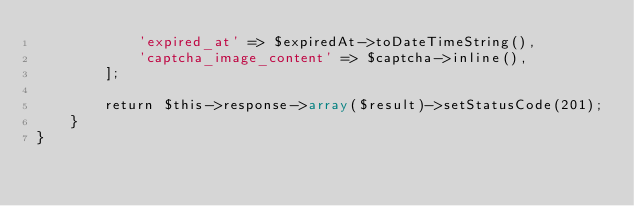Convert code to text. <code><loc_0><loc_0><loc_500><loc_500><_PHP_>			'expired_at' => $expiredAt->toDateTimeString(),
			'captcha_image_content' => $captcha->inline(),
		];

		return $this->response->array($result)->setStatusCode(201);
	}
}
</code> 